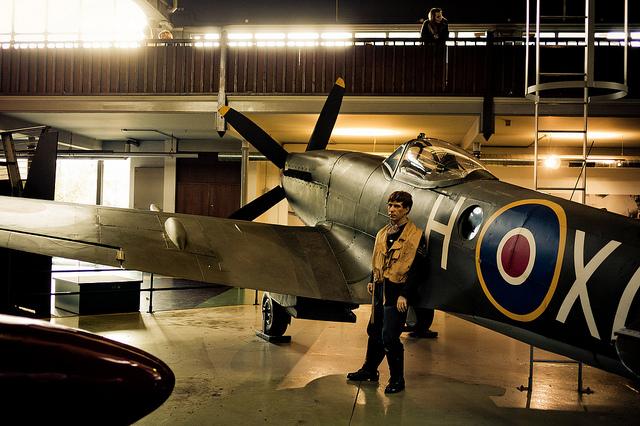What color is the plane?
Keep it brief. Black. Is the man remodeling the airplane?
Short answer required. No. Is this a new airplane?
Keep it brief. No. 